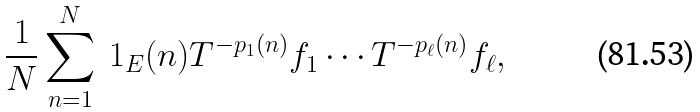Convert formula to latex. <formula><loc_0><loc_0><loc_500><loc_500>\frac { 1 } { N } \sum _ { n = 1 } ^ { N } \ 1 _ { E } ( n ) T ^ { - p _ { 1 } ( n ) } f _ { 1 } \cdots T ^ { - p _ { \ell } ( n ) } f _ { \ell } ,</formula> 